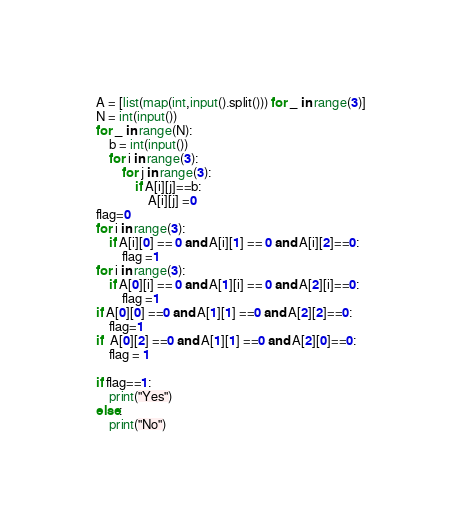Convert code to text. <code><loc_0><loc_0><loc_500><loc_500><_Python_>A = [list(map(int,input().split())) for _ in range(3)]
N = int(input())
for _ in range(N):
    b = int(input())
    for i in range(3):
        for j in range(3):
            if A[i][j]==b:
                A[i][j] =0
flag=0
for i in range(3):
    if A[i][0] == 0 and A[i][1] == 0 and A[i][2]==0:
        flag =1
for i in range(3):
    if A[0][i] == 0 and A[1][i] == 0 and A[2][i]==0:
        flag =1
if A[0][0] ==0 and A[1][1] ==0 and A[2][2]==0:
    flag=1
if  A[0][2] ==0 and A[1][1] ==0 and A[2][0]==0:
    flag = 1

if flag==1:
    print("Yes")
else:
    print("No")</code> 